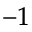Convert formula to latex. <formula><loc_0><loc_0><loc_500><loc_500>^ { - 1 }</formula> 